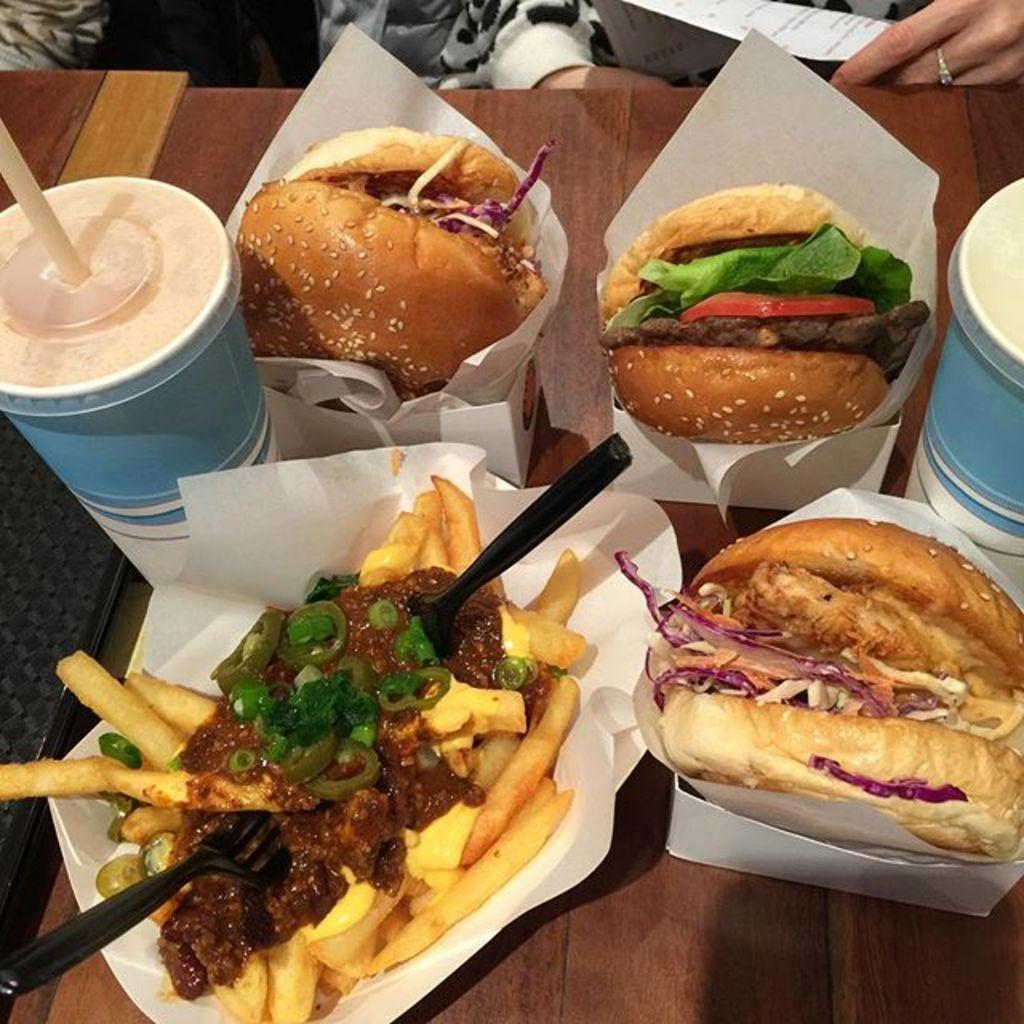What types of items can be seen in the image? There are food items, boxes, glasses, a straw, a fork, and a spoon in the image. What is the object in the image? The object in the image is not specified, but it is mentioned that there is an object present. Where are the items placed in the image? The items are placed on a platform in the image. Can you describe the background of the image? In the background of the image, there are people and a paper visible. How does the credit affect the bell in the image? There is no credit or bell present in the image, so this question cannot be answered. 